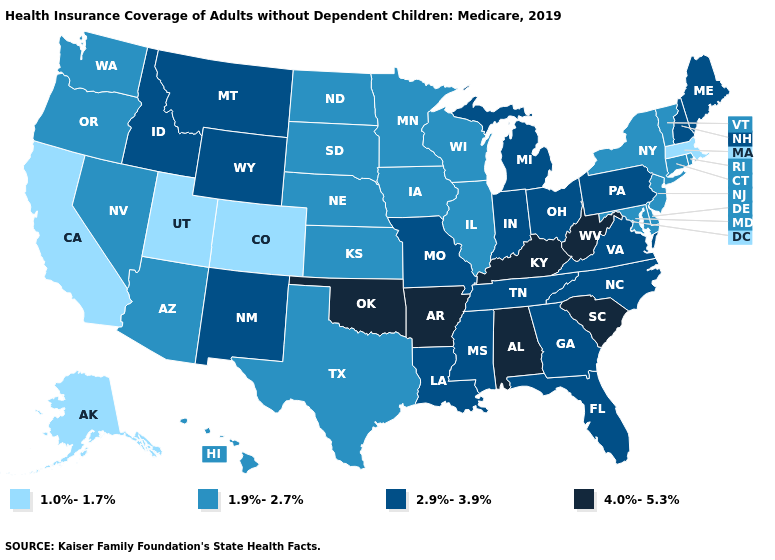Name the states that have a value in the range 1.9%-2.7%?
Short answer required. Arizona, Connecticut, Delaware, Hawaii, Illinois, Iowa, Kansas, Maryland, Minnesota, Nebraska, Nevada, New Jersey, New York, North Dakota, Oregon, Rhode Island, South Dakota, Texas, Vermont, Washington, Wisconsin. Does the first symbol in the legend represent the smallest category?
Write a very short answer. Yes. Among the states that border Indiana , does Kentucky have the lowest value?
Quick response, please. No. What is the value of Minnesota?
Short answer required. 1.9%-2.7%. What is the value of Ohio?
Answer briefly. 2.9%-3.9%. What is the lowest value in the Northeast?
Concise answer only. 1.0%-1.7%. What is the value of Florida?
Answer briefly. 2.9%-3.9%. What is the value of Indiana?
Keep it brief. 2.9%-3.9%. Name the states that have a value in the range 1.0%-1.7%?
Quick response, please. Alaska, California, Colorado, Massachusetts, Utah. Name the states that have a value in the range 1.0%-1.7%?
Be succinct. Alaska, California, Colorado, Massachusetts, Utah. What is the value of Oklahoma?
Short answer required. 4.0%-5.3%. What is the lowest value in the Northeast?
Short answer required. 1.0%-1.7%. Among the states that border Delaware , which have the highest value?
Quick response, please. Pennsylvania. What is the value of Florida?
Concise answer only. 2.9%-3.9%. 